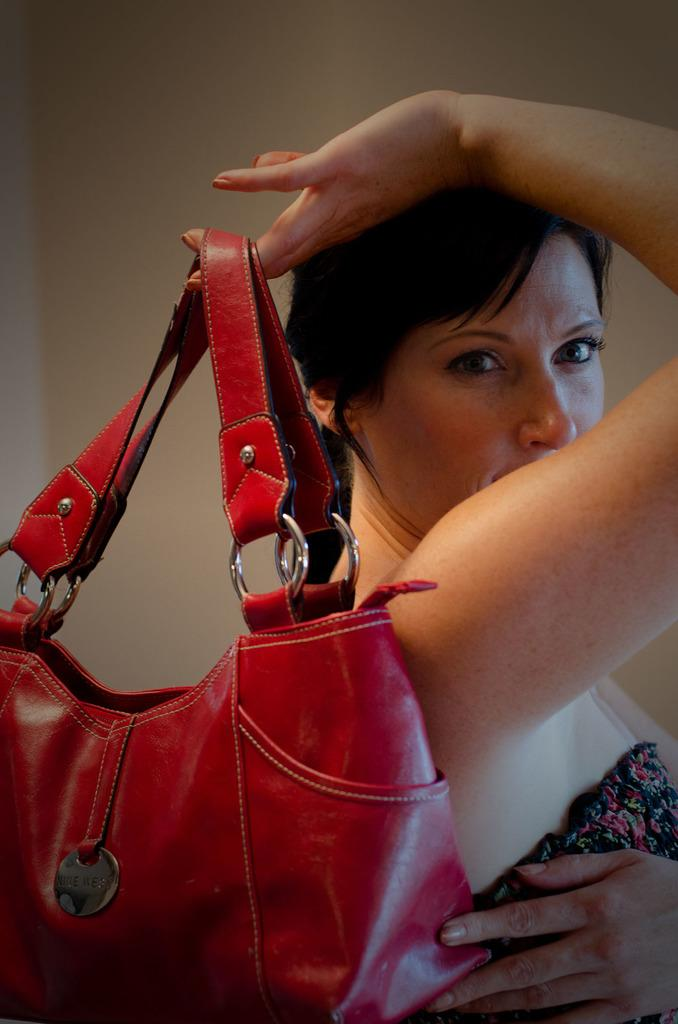Who is present in the image? There is a woman in the image. What is the woman holding in the image? The woman is holding a shiny red handbag. What is the woman wearing in the image? The woman is wearing a black dress. What can be seen in the background of the image? There is a wall in the background of the image. Can you see any goldfish swimming in the image? There are no goldfish present in the image. 